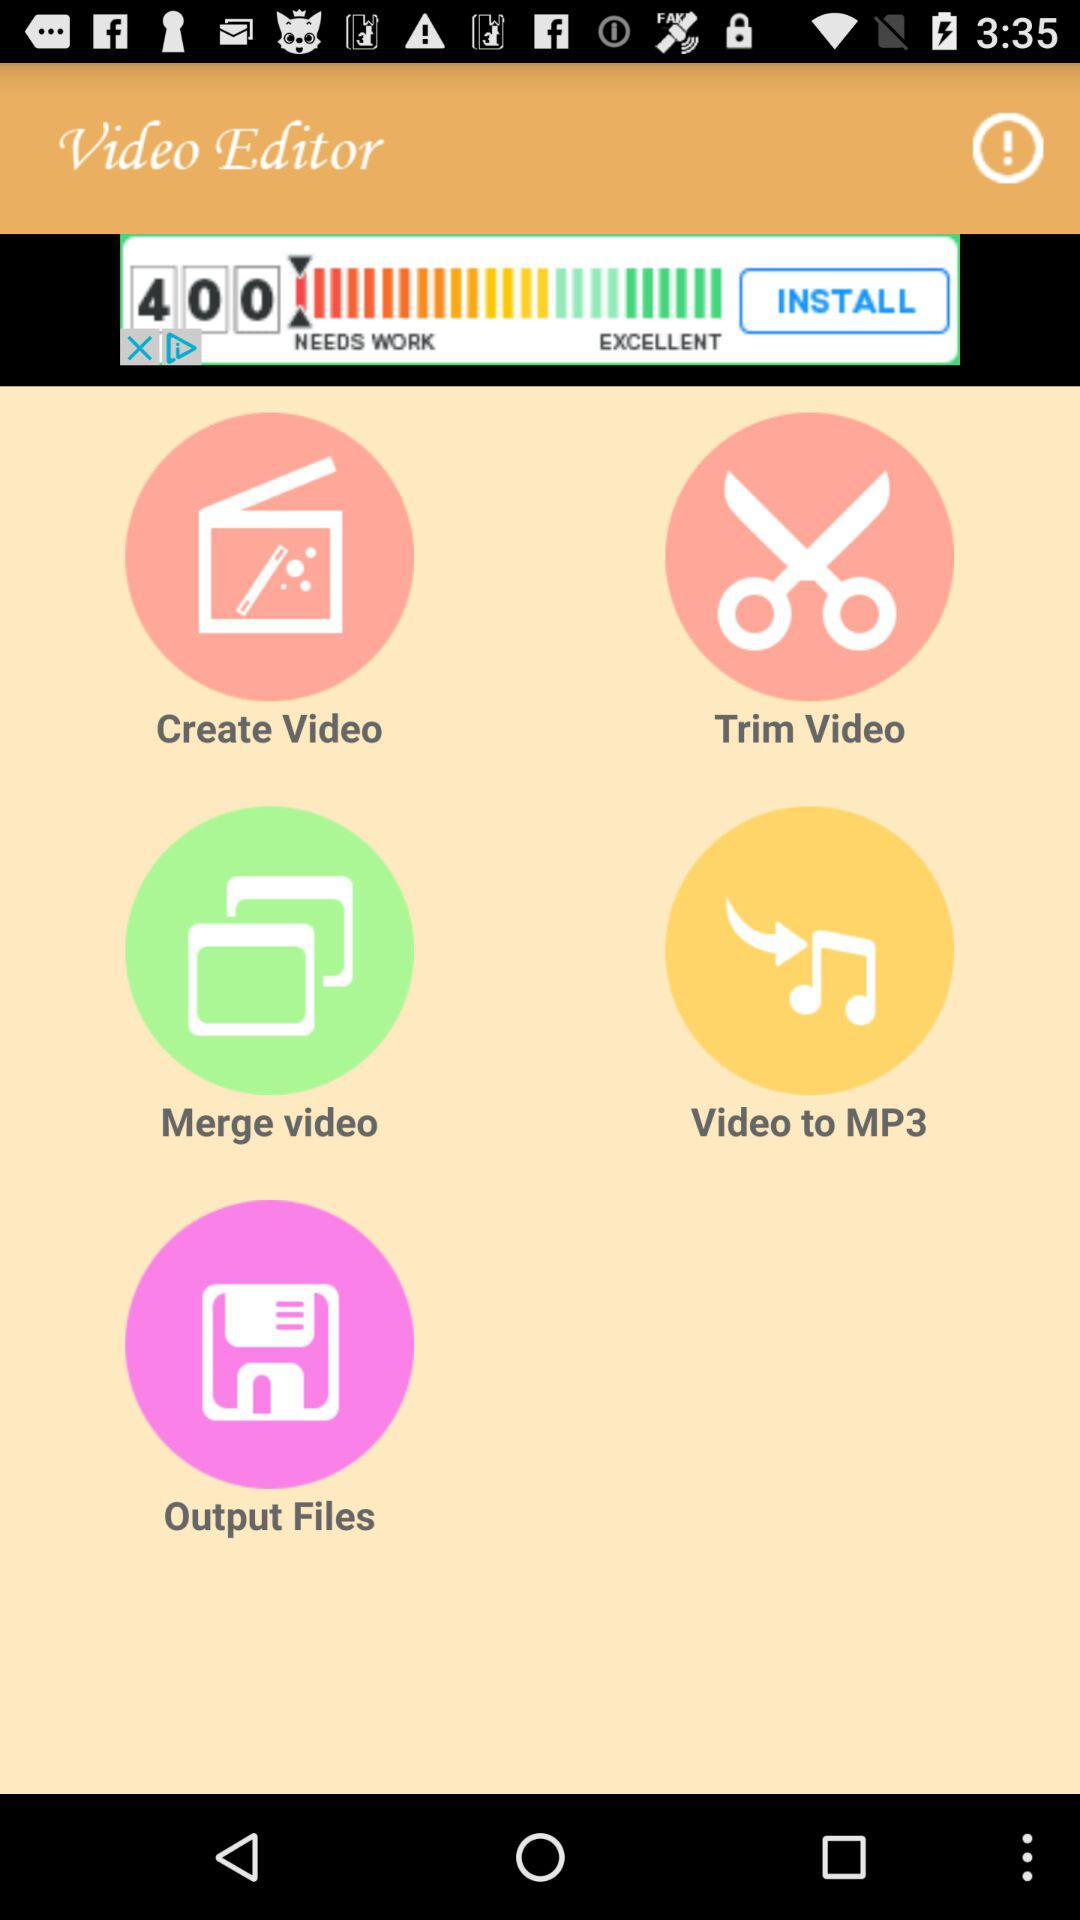What is the app name? The app name is "Video Editor". 